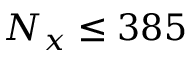<formula> <loc_0><loc_0><loc_500><loc_500>N _ { x } \leq 3 8 5</formula> 